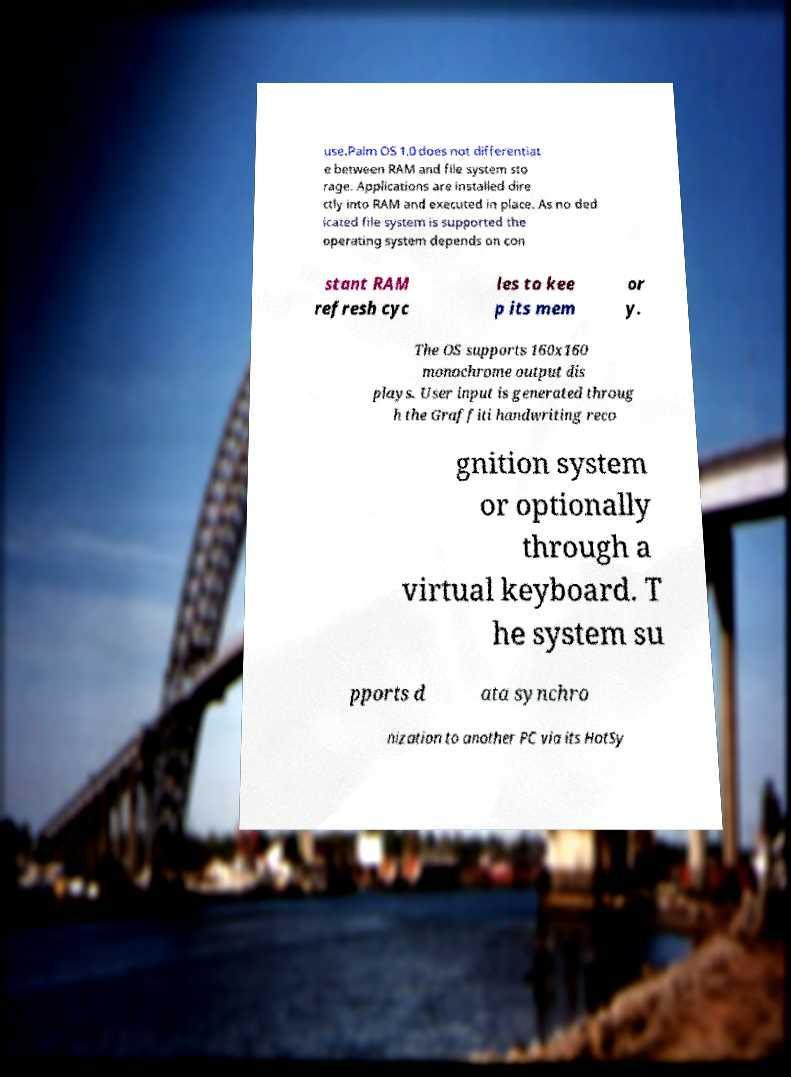There's text embedded in this image that I need extracted. Can you transcribe it verbatim? use.Palm OS 1.0 does not differentiat e between RAM and file system sto rage. Applications are installed dire ctly into RAM and executed in place. As no ded icated file system is supported the operating system depends on con stant RAM refresh cyc les to kee p its mem or y. The OS supports 160x160 monochrome output dis plays. User input is generated throug h the Graffiti handwriting reco gnition system or optionally through a virtual keyboard. T he system su pports d ata synchro nization to another PC via its HotSy 